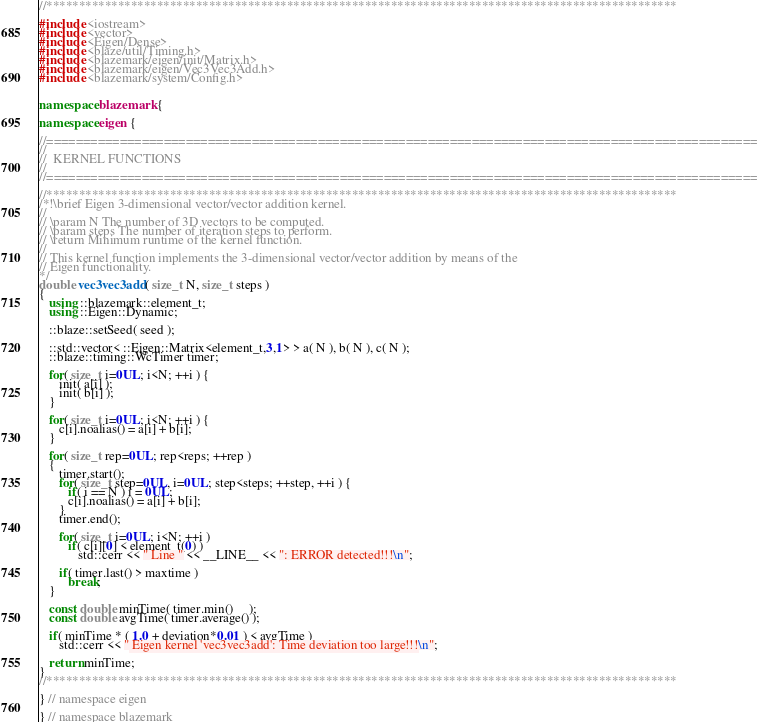Convert code to text. <code><loc_0><loc_0><loc_500><loc_500><_C++_>//*************************************************************************************************

#include <iostream>
#include <vector>
#include <Eigen/Dense>
#include <blaze/util/Timing.h>
#include <blazemark/eigen/init/Matrix.h>
#include <blazemark/eigen/Vec3Vec3Add.h>
#include <blazemark/system/Config.h>


namespace blazemark {

namespace eigen {

//=================================================================================================
//
//  KERNEL FUNCTIONS
//
//=================================================================================================

//*************************************************************************************************
/*!\brief Eigen 3-dimensional vector/vector addition kernel.
//
// \param N The number of 3D vectors to be computed.
// \param steps The number of iteration steps to perform.
// \return Minimum runtime of the kernel function.
//
// This kernel function implements the 3-dimensional vector/vector addition by means of the
// Eigen functionality.
*/
double vec3vec3add( size_t N, size_t steps )
{
   using ::blazemark::element_t;
   using ::Eigen::Dynamic;

   ::blaze::setSeed( seed );

   ::std::vector< ::Eigen::Matrix<element_t,3,1> > a( N ), b( N ), c( N );
   ::blaze::timing::WcTimer timer;

   for( size_t i=0UL; i<N; ++i ) {
      init( a[i] );
      init( b[i] );
   }

   for( size_t i=0UL; i<N; ++i ) {
      c[i].noalias() = a[i] + b[i];
   }

   for( size_t rep=0UL; rep<reps; ++rep )
   {
      timer.start();
      for( size_t step=0UL, i=0UL; step<steps; ++step, ++i ) {
         if( i == N ) i = 0UL;
         c[i].noalias() = a[i] + b[i];
      }
      timer.end();

      for( size_t i=0UL; i<N; ++i )
         if( c[i][0] < element_t(0) )
            std::cerr << " Line " << __LINE__ << ": ERROR detected!!!\n";

      if( timer.last() > maxtime )
         break;
   }

   const double minTime( timer.min()     );
   const double avgTime( timer.average() );

   if( minTime * ( 1.0 + deviation*0.01 ) < avgTime )
      std::cerr << " Eigen kernel 'vec3vec3add': Time deviation too large!!!\n";

   return minTime;
}
//*************************************************************************************************

} // namespace eigen

} // namespace blazemark
</code> 